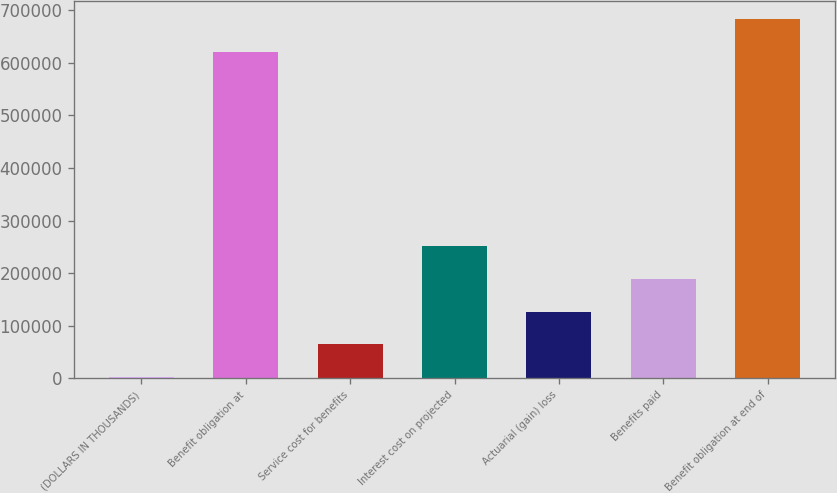Convert chart to OTSL. <chart><loc_0><loc_0><loc_500><loc_500><bar_chart><fcel>(DOLLARS IN THOUSANDS)<fcel>Benefit obligation at<fcel>Service cost for benefits<fcel>Interest cost on projected<fcel>Actuarial (gain) loss<fcel>Benefits paid<fcel>Benefit obligation at end of<nl><fcel>2010<fcel>621259<fcel>64314.2<fcel>251227<fcel>126618<fcel>188923<fcel>683563<nl></chart> 